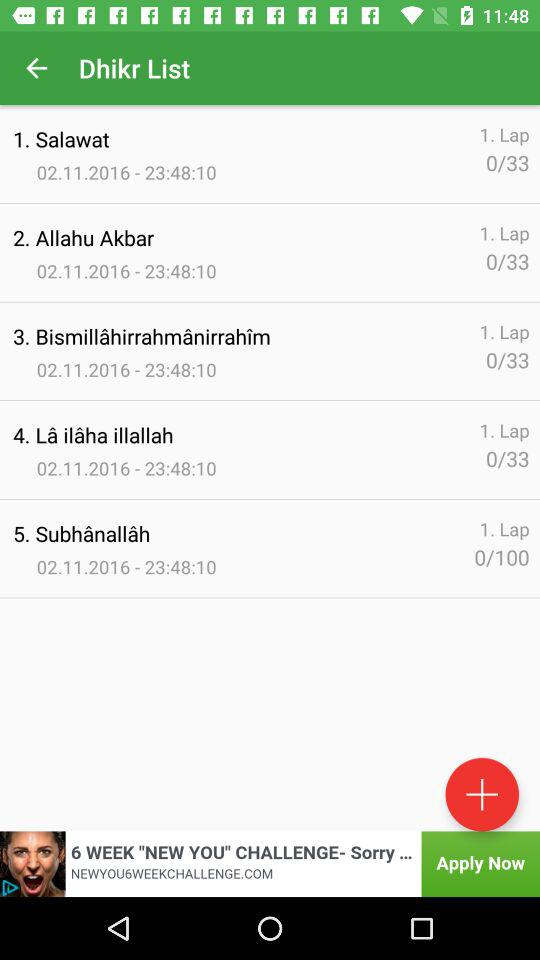How many dhikr are there in total?
Answer the question using a single word or phrase. 5 